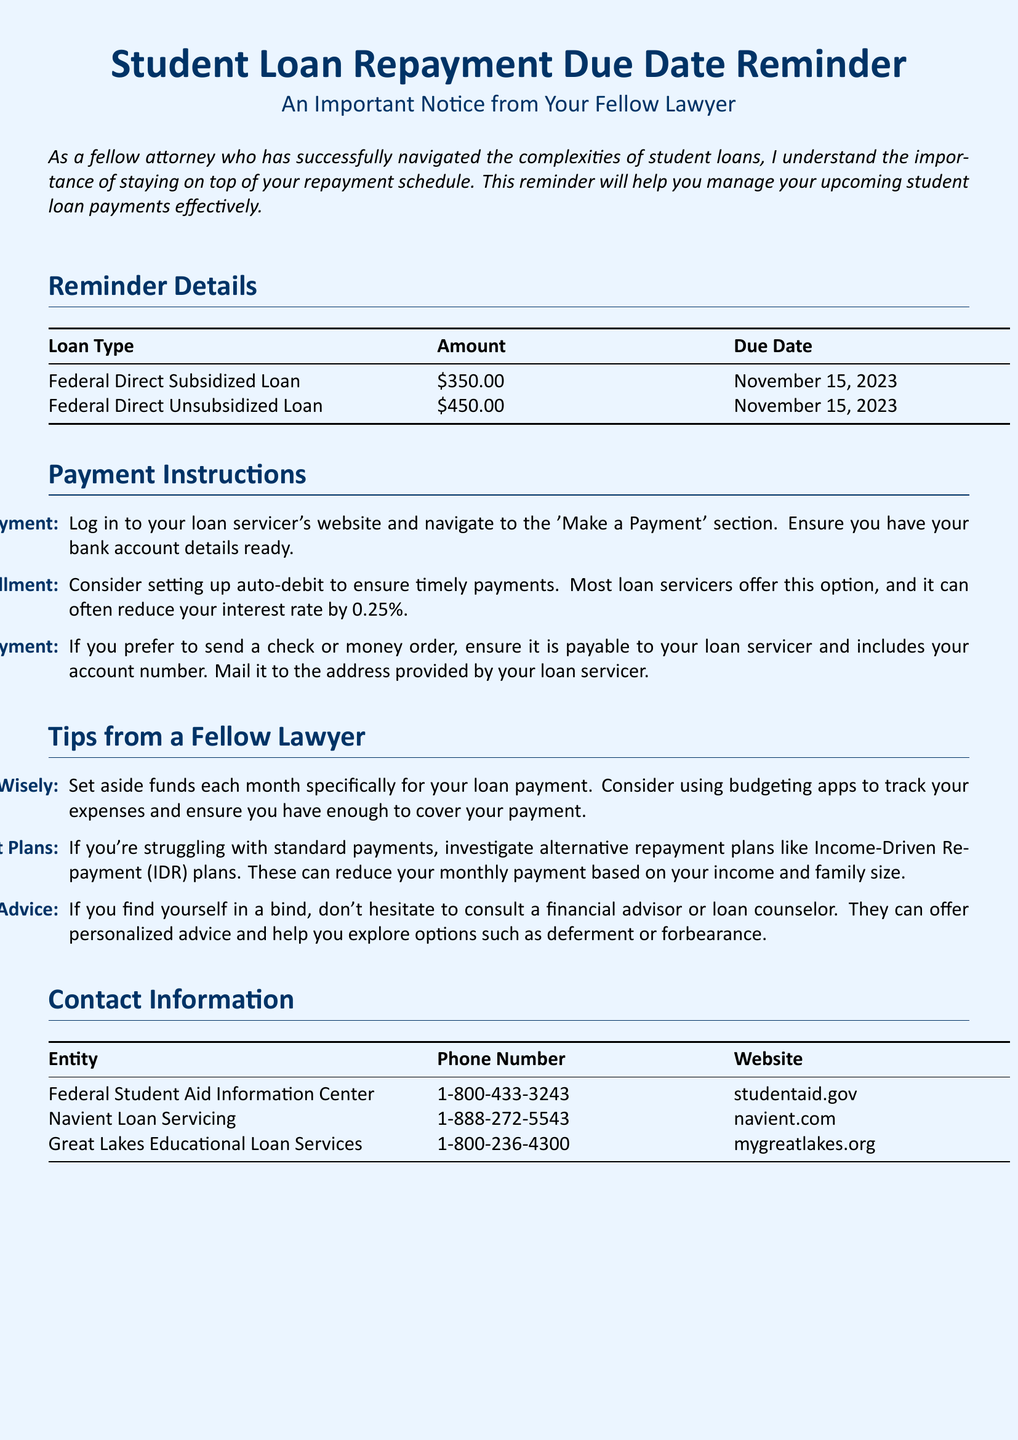What is the amount due for the Federal Direct Subsidized Loan? The amount due for the Federal Direct Subsidized Loan is listed in the table under the amount column.
Answer: $350.00 When is the due date for the loans? The due date for both loans is specified in the table under the due date column.
Answer: November 15, 2023 What is one option provided for making an online payment? The document outlines the instructions for making an online payment, specifically mentioning which section to navigate to on the loan servicer's website.
Answer: 'Make a Payment' section How can enrolling in auto-debit benefit borrowers? The document states that setting up auto-debit can have financial benefits explained in the payment instructions section.
Answer: Reduce interest rate by 0.25% What advice is given for budgeting? The tips section includes specific recommendations for budgeting effectively to manage loan payments.
Answer: Set aside funds each month Which entity is listed first in the contact information table? The entities are listed in a table with their corresponding phone numbers and websites, guiding borrowers on whom to contact.
Answer: Federal Student Aid Information Center What type of loan is associated with a $450.00 payment? The table categorizes the loans and their amounts, allowing for easy identification of each loan type.
Answer: Federal Direct Unsubsidized Loan What should borrowers do if they are struggling with payments? The document provides strategies in the tips section, highlighting options available for individuals facing difficulties.
Answer: Investigate alternative repayment plans In which section can borrowers find tips from a fellow lawyer? The tips provided in the document are categorized under a specific section designed to share insights from the author's experience.
Answer: Tips from a Fellow Lawyer 